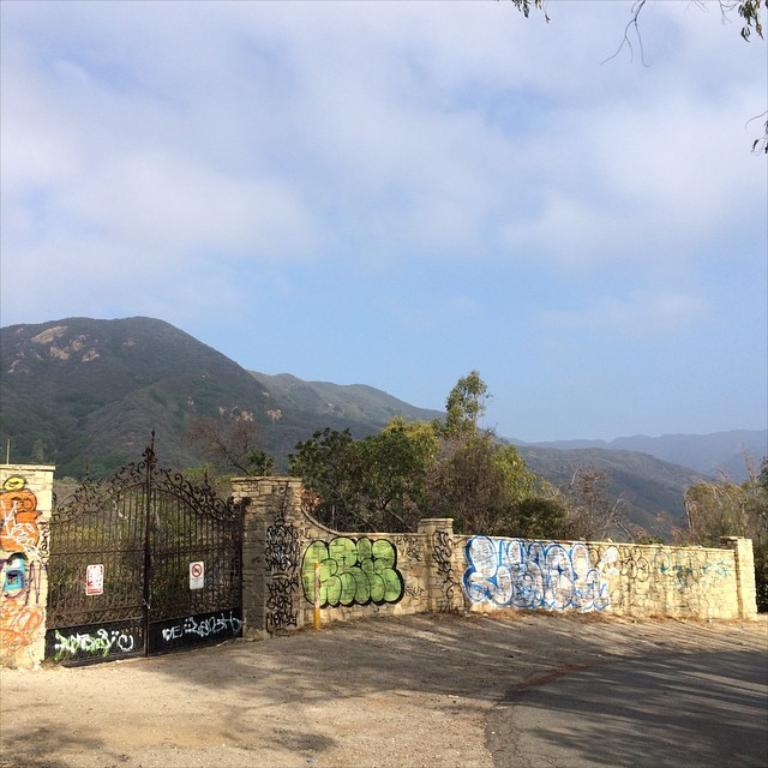Describe this image in one or two sentences. In this image, we can see paintings on the wall and pillars. Here we can see two posts are on the gate. At the bottom, we can see walkway and road. Background there are so many trees, hills and sky. 